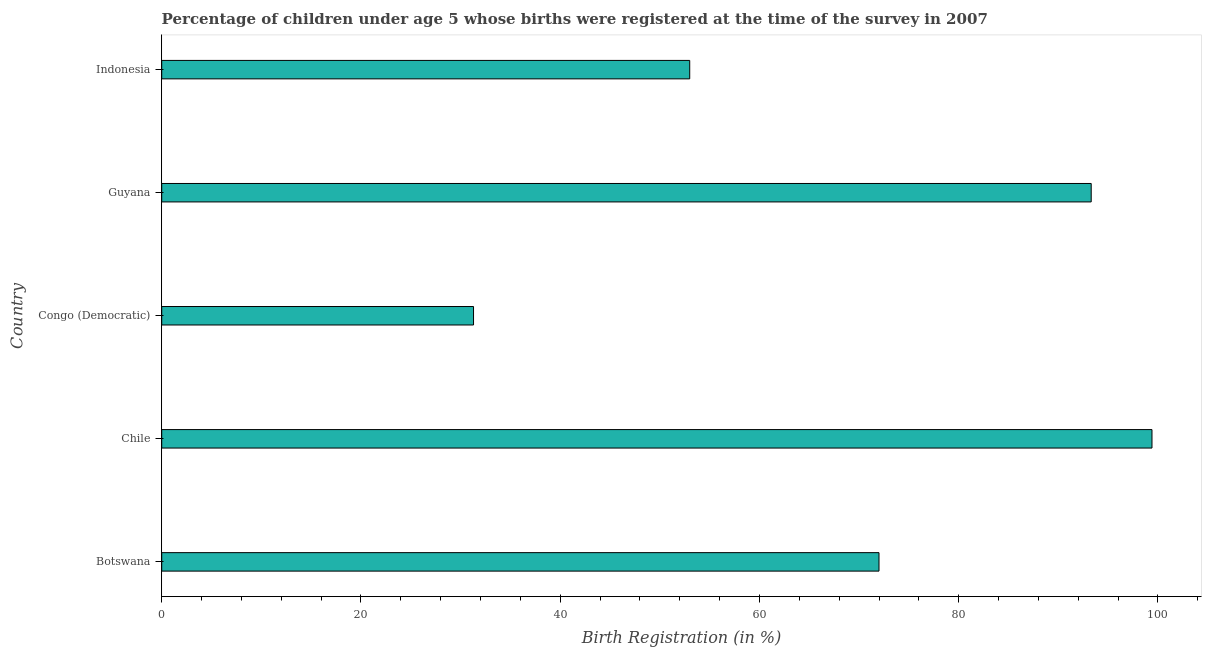What is the title of the graph?
Make the answer very short. Percentage of children under age 5 whose births were registered at the time of the survey in 2007. What is the label or title of the X-axis?
Give a very brief answer. Birth Registration (in %). What is the label or title of the Y-axis?
Offer a terse response. Country. What is the birth registration in Indonesia?
Provide a short and direct response. 53. Across all countries, what is the maximum birth registration?
Offer a terse response. 99.4. Across all countries, what is the minimum birth registration?
Your response must be concise. 31.3. In which country was the birth registration minimum?
Offer a very short reply. Congo (Democratic). What is the sum of the birth registration?
Provide a succinct answer. 349. What is the difference between the birth registration in Chile and Congo (Democratic)?
Ensure brevity in your answer.  68.1. What is the average birth registration per country?
Give a very brief answer. 69.8. What is the median birth registration?
Provide a succinct answer. 72. In how many countries, is the birth registration greater than 60 %?
Provide a short and direct response. 3. What is the ratio of the birth registration in Congo (Democratic) to that in Guyana?
Keep it short and to the point. 0.34. What is the difference between the highest and the second highest birth registration?
Offer a very short reply. 6.1. Is the sum of the birth registration in Congo (Democratic) and Indonesia greater than the maximum birth registration across all countries?
Provide a succinct answer. No. What is the difference between the highest and the lowest birth registration?
Give a very brief answer. 68.1. How many bars are there?
Provide a short and direct response. 5. How many countries are there in the graph?
Ensure brevity in your answer.  5. What is the difference between two consecutive major ticks on the X-axis?
Your answer should be compact. 20. What is the Birth Registration (in %) of Chile?
Ensure brevity in your answer.  99.4. What is the Birth Registration (in %) of Congo (Democratic)?
Your answer should be very brief. 31.3. What is the Birth Registration (in %) of Guyana?
Give a very brief answer. 93.3. What is the Birth Registration (in %) in Indonesia?
Give a very brief answer. 53. What is the difference between the Birth Registration (in %) in Botswana and Chile?
Provide a succinct answer. -27.4. What is the difference between the Birth Registration (in %) in Botswana and Congo (Democratic)?
Give a very brief answer. 40.7. What is the difference between the Birth Registration (in %) in Botswana and Guyana?
Your response must be concise. -21.3. What is the difference between the Birth Registration (in %) in Botswana and Indonesia?
Your response must be concise. 19. What is the difference between the Birth Registration (in %) in Chile and Congo (Democratic)?
Keep it short and to the point. 68.1. What is the difference between the Birth Registration (in %) in Chile and Guyana?
Provide a short and direct response. 6.1. What is the difference between the Birth Registration (in %) in Chile and Indonesia?
Offer a very short reply. 46.4. What is the difference between the Birth Registration (in %) in Congo (Democratic) and Guyana?
Offer a terse response. -62. What is the difference between the Birth Registration (in %) in Congo (Democratic) and Indonesia?
Provide a succinct answer. -21.7. What is the difference between the Birth Registration (in %) in Guyana and Indonesia?
Give a very brief answer. 40.3. What is the ratio of the Birth Registration (in %) in Botswana to that in Chile?
Your answer should be very brief. 0.72. What is the ratio of the Birth Registration (in %) in Botswana to that in Guyana?
Keep it short and to the point. 0.77. What is the ratio of the Birth Registration (in %) in Botswana to that in Indonesia?
Your answer should be compact. 1.36. What is the ratio of the Birth Registration (in %) in Chile to that in Congo (Democratic)?
Offer a terse response. 3.18. What is the ratio of the Birth Registration (in %) in Chile to that in Guyana?
Offer a terse response. 1.06. What is the ratio of the Birth Registration (in %) in Chile to that in Indonesia?
Ensure brevity in your answer.  1.88. What is the ratio of the Birth Registration (in %) in Congo (Democratic) to that in Guyana?
Offer a terse response. 0.34. What is the ratio of the Birth Registration (in %) in Congo (Democratic) to that in Indonesia?
Keep it short and to the point. 0.59. What is the ratio of the Birth Registration (in %) in Guyana to that in Indonesia?
Give a very brief answer. 1.76. 